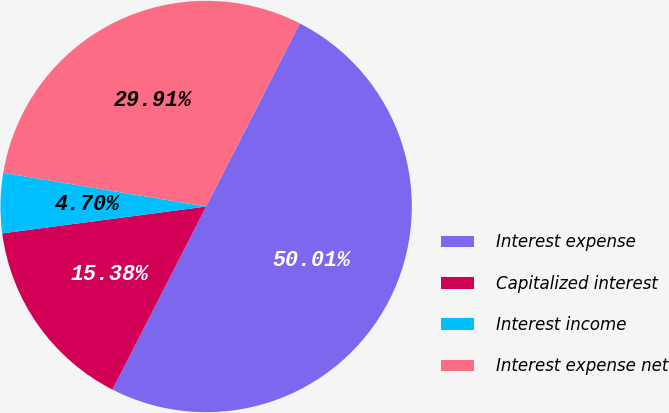Convert chart. <chart><loc_0><loc_0><loc_500><loc_500><pie_chart><fcel>Interest expense<fcel>Capitalized interest<fcel>Interest income<fcel>Interest expense net<nl><fcel>50.0%<fcel>15.38%<fcel>4.7%<fcel>29.91%<nl></chart> 